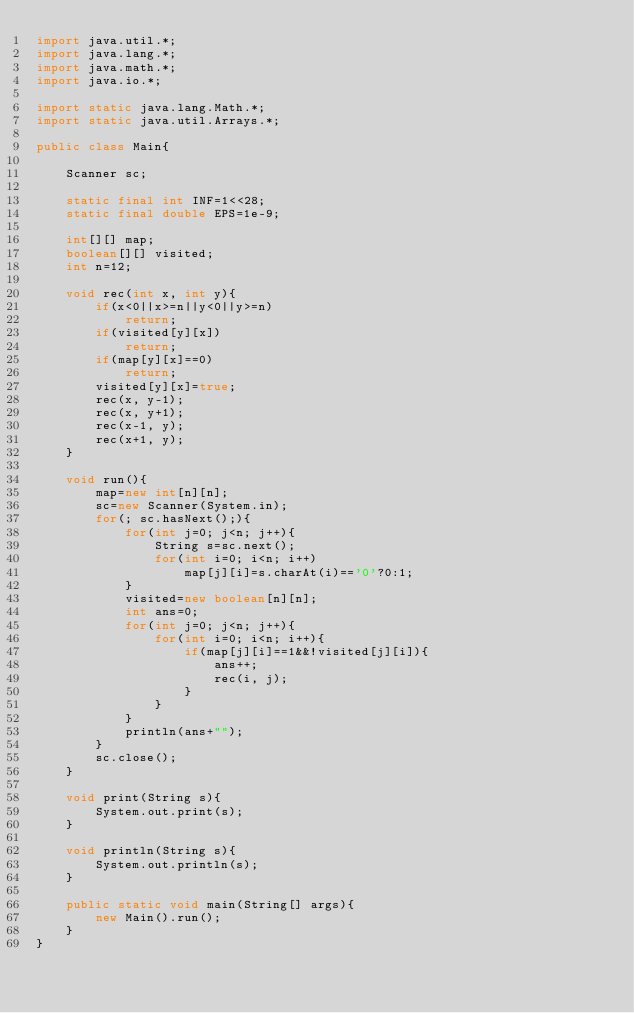<code> <loc_0><loc_0><loc_500><loc_500><_Java_>import java.util.*;
import java.lang.*;
import java.math.*;
import java.io.*;

import static java.lang.Math.*;
import static java.util.Arrays.*;

public class Main{

	Scanner sc;

	static final int INF=1<<28;
	static final double EPS=1e-9;

	int[][] map;
	boolean[][] visited;
	int n=12;

	void rec(int x, int y){
		if(x<0||x>=n||y<0||y>=n)
			return;
		if(visited[y][x])
			return;
		if(map[y][x]==0)
			return;
		visited[y][x]=true;
		rec(x, y-1);
		rec(x, y+1);
		rec(x-1, y);
		rec(x+1, y);
	}

	void run(){
		map=new int[n][n];
		sc=new Scanner(System.in);
		for(; sc.hasNext();){
			for(int j=0; j<n; j++){
				String s=sc.next();
				for(int i=0; i<n; i++)
					map[j][i]=s.charAt(i)=='0'?0:1;
			}
			visited=new boolean[n][n];
			int ans=0;
			for(int j=0; j<n; j++){
				for(int i=0; i<n; i++){
					if(map[j][i]==1&&!visited[j][i]){
						ans++;
						rec(i, j);
					}
				}
			}
			println(ans+"");
		}
		sc.close();
	}

	void print(String s){
		System.out.print(s);
	}

	void println(String s){
		System.out.println(s);
	}

	public static void main(String[] args){
		new Main().run();
	}
}</code> 